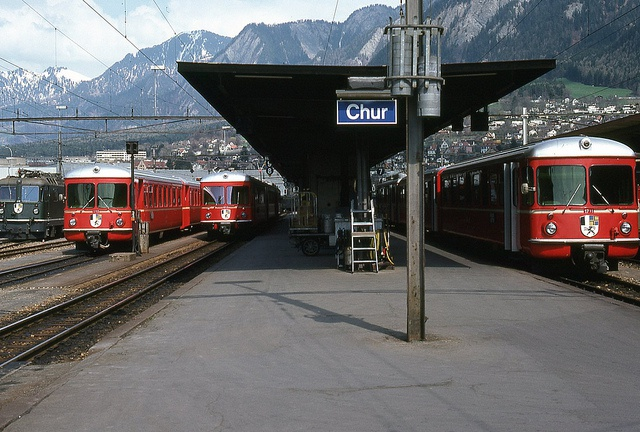Describe the objects in this image and their specific colors. I can see train in lightblue, black, brown, gray, and white tones, train in lightblue, maroon, black, brown, and gray tones, train in lightblue, black, brown, white, and maroon tones, and train in lightblue, black, gray, darkgray, and purple tones in this image. 